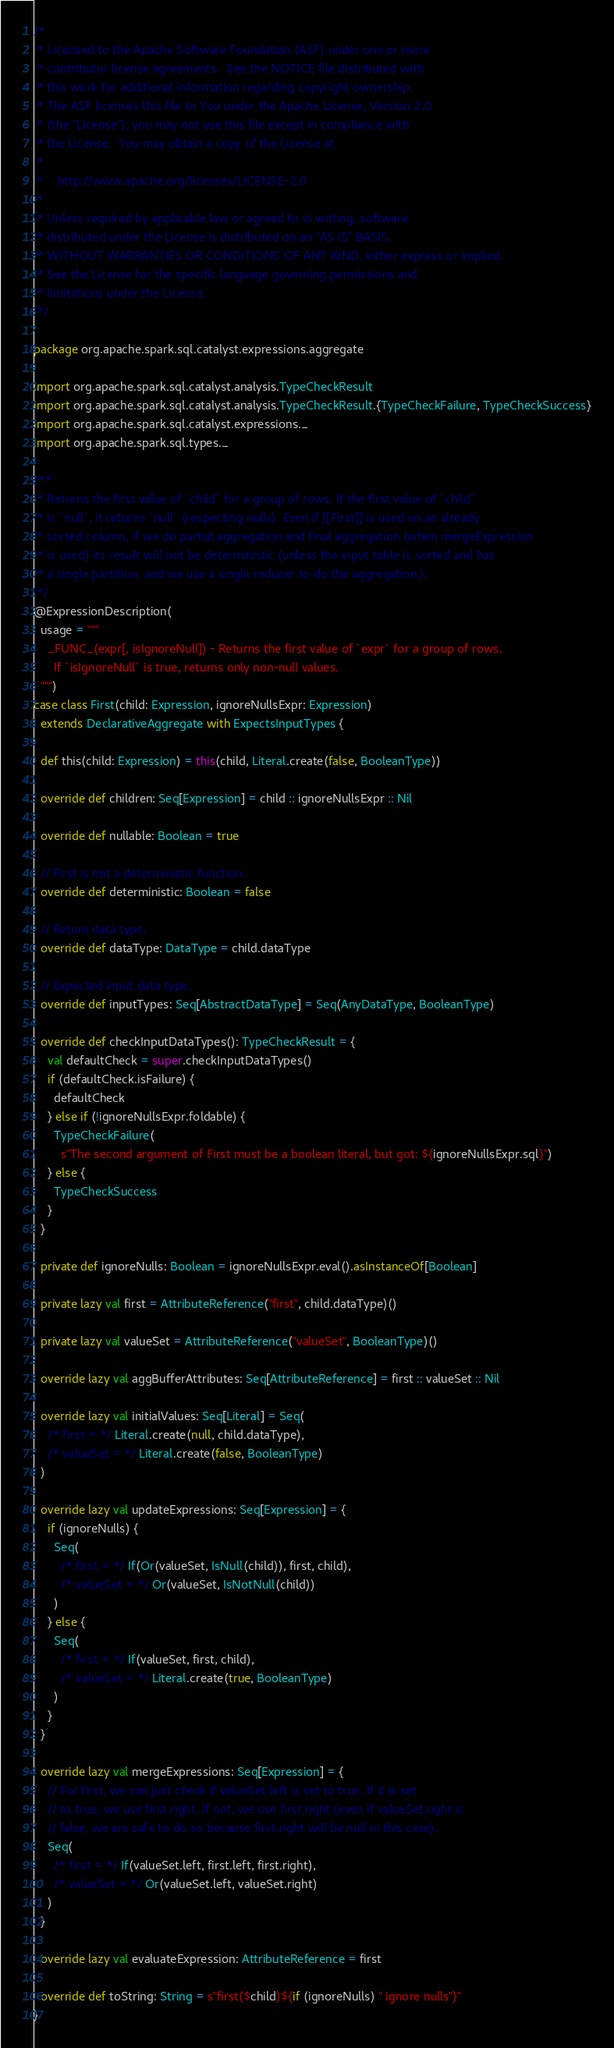Convert code to text. <code><loc_0><loc_0><loc_500><loc_500><_Scala_>/*
 * Licensed to the Apache Software Foundation (ASF) under one or more
 * contributor license agreements.  See the NOTICE file distributed with
 * this work for additional information regarding copyright ownership.
 * The ASF licenses this file to You under the Apache License, Version 2.0
 * (the "License"); you may not use this file except in compliance with
 * the License.  You may obtain a copy of the License at
 *
 *    http://www.apache.org/licenses/LICENSE-2.0
 *
 * Unless required by applicable law or agreed to in writing, software
 * distributed under the License is distributed on an "AS IS" BASIS,
 * WITHOUT WARRANTIES OR CONDITIONS OF ANY KIND, either express or implied.
 * See the License for the specific language governing permissions and
 * limitations under the License.
 */

package org.apache.spark.sql.catalyst.expressions.aggregate

import org.apache.spark.sql.catalyst.analysis.TypeCheckResult
import org.apache.spark.sql.catalyst.analysis.TypeCheckResult.{TypeCheckFailure, TypeCheckSuccess}
import org.apache.spark.sql.catalyst.expressions._
import org.apache.spark.sql.types._

/**
 * Returns the first value of `child` for a group of rows. If the first value of `child`
 * is `null`, it returns `null` (respecting nulls). Even if [[First]] is used on an already
 * sorted column, if we do partial aggregation and final aggregation (when mergeExpression
 * is used) its result will not be deterministic (unless the input table is sorted and has
 * a single partition, and we use a single reducer to do the aggregation.).
 */
@ExpressionDescription(
  usage = """
    _FUNC_(expr[, isIgnoreNull]) - Returns the first value of `expr` for a group of rows.
      If `isIgnoreNull` is true, returns only non-null values.
  """)
case class First(child: Expression, ignoreNullsExpr: Expression)
  extends DeclarativeAggregate with ExpectsInputTypes {

  def this(child: Expression) = this(child, Literal.create(false, BooleanType))

  override def children: Seq[Expression] = child :: ignoreNullsExpr :: Nil

  override def nullable: Boolean = true

  // First is not a deterministic function.
  override def deterministic: Boolean = false

  // Return data type.
  override def dataType: DataType = child.dataType

  // Expected input data type.
  override def inputTypes: Seq[AbstractDataType] = Seq(AnyDataType, BooleanType)

  override def checkInputDataTypes(): TypeCheckResult = {
    val defaultCheck = super.checkInputDataTypes()
    if (defaultCheck.isFailure) {
      defaultCheck
    } else if (!ignoreNullsExpr.foldable) {
      TypeCheckFailure(
        s"The second argument of First must be a boolean literal, but got: ${ignoreNullsExpr.sql}")
    } else {
      TypeCheckSuccess
    }
  }

  private def ignoreNulls: Boolean = ignoreNullsExpr.eval().asInstanceOf[Boolean]

  private lazy val first = AttributeReference("first", child.dataType)()

  private lazy val valueSet = AttributeReference("valueSet", BooleanType)()

  override lazy val aggBufferAttributes: Seq[AttributeReference] = first :: valueSet :: Nil

  override lazy val initialValues: Seq[Literal] = Seq(
    /* first = */ Literal.create(null, child.dataType),
    /* valueSet = */ Literal.create(false, BooleanType)
  )

  override lazy val updateExpressions: Seq[Expression] = {
    if (ignoreNulls) {
      Seq(
        /* first = */ If(Or(valueSet, IsNull(child)), first, child),
        /* valueSet = */ Or(valueSet, IsNotNull(child))
      )
    } else {
      Seq(
        /* first = */ If(valueSet, first, child),
        /* valueSet = */ Literal.create(true, BooleanType)
      )
    }
  }

  override lazy val mergeExpressions: Seq[Expression] = {
    // For first, we can just check if valueSet.left is set to true. If it is set
    // to true, we use first.right. If not, we use first.right (even if valueSet.right is
    // false, we are safe to do so because first.right will be null in this case).
    Seq(
      /* first = */ If(valueSet.left, first.left, first.right),
      /* valueSet = */ Or(valueSet.left, valueSet.right)
    )
  }

  override lazy val evaluateExpression: AttributeReference = first

  override def toString: String = s"first($child)${if (ignoreNulls) " ignore nulls"}"
}
</code> 